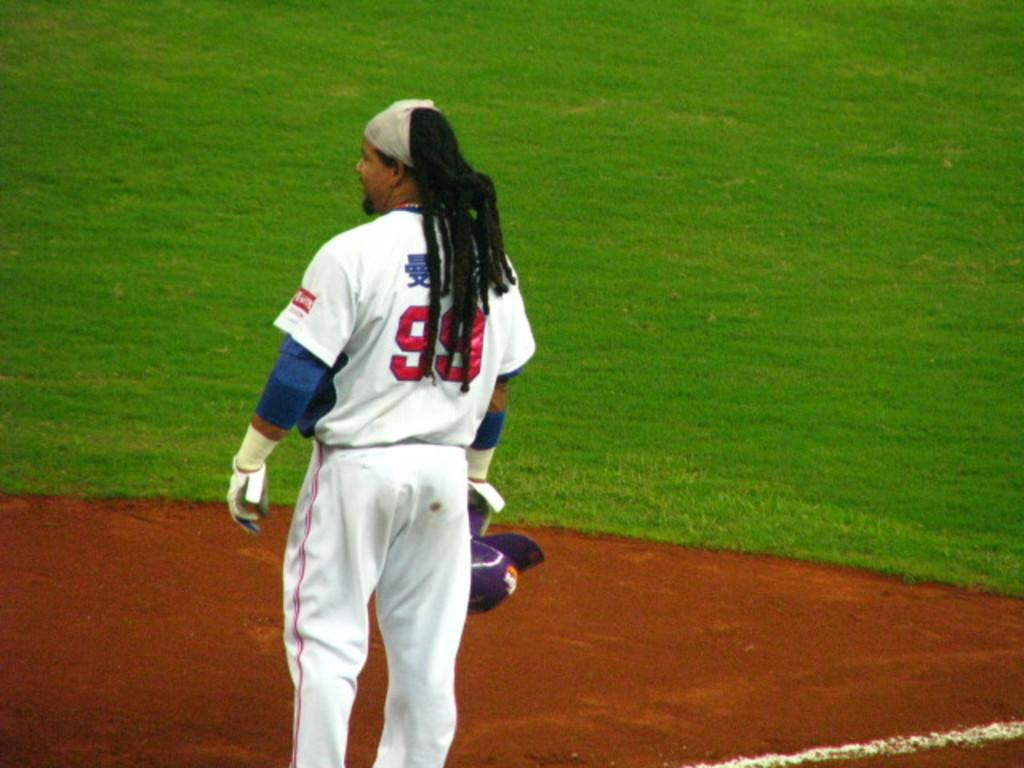Who is present in the image? There is a man in the image. What is the man wearing? The man is wearing a white jersey and pants. Where is the man standing? The man is standing on a play field. What can be seen in the background of the image? There is a grass field in the background of the image. What type of toothpaste is the man using in the image? There is no toothpaste present in the image; the man is standing on a play field wearing a white jersey and pants. 